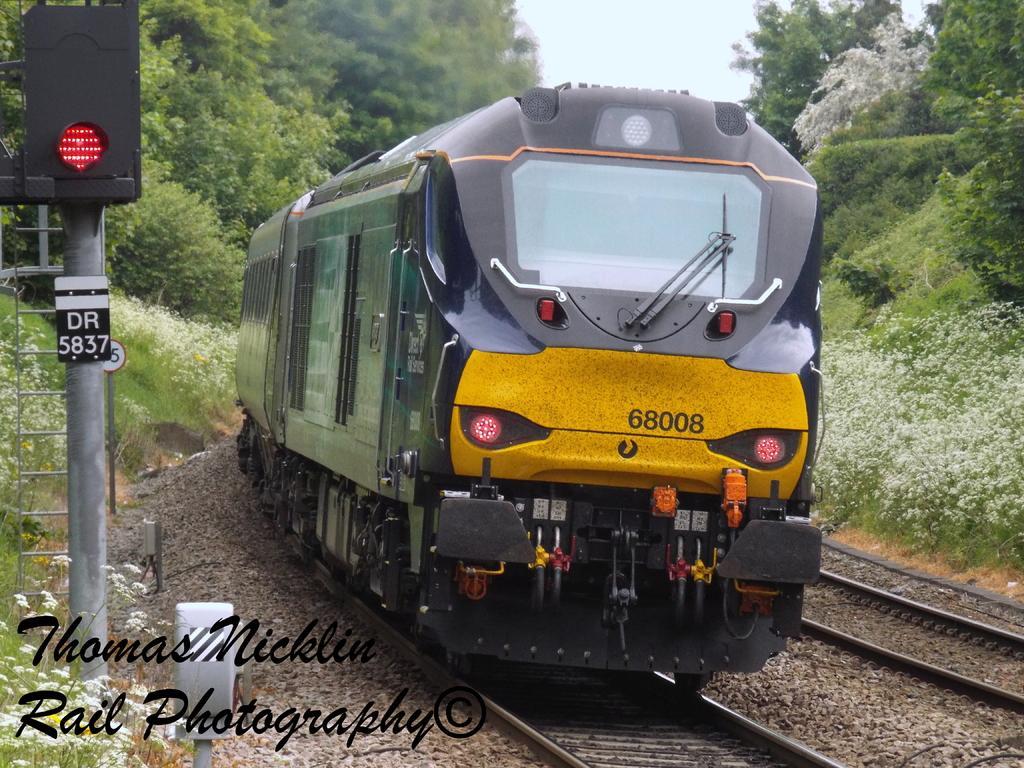Can you describe this image briefly? Here we can see a train on the railway track and on the left we can see a signal pole,ladder and some metal items. In the background there are trees,plants with white flowers and sky. 